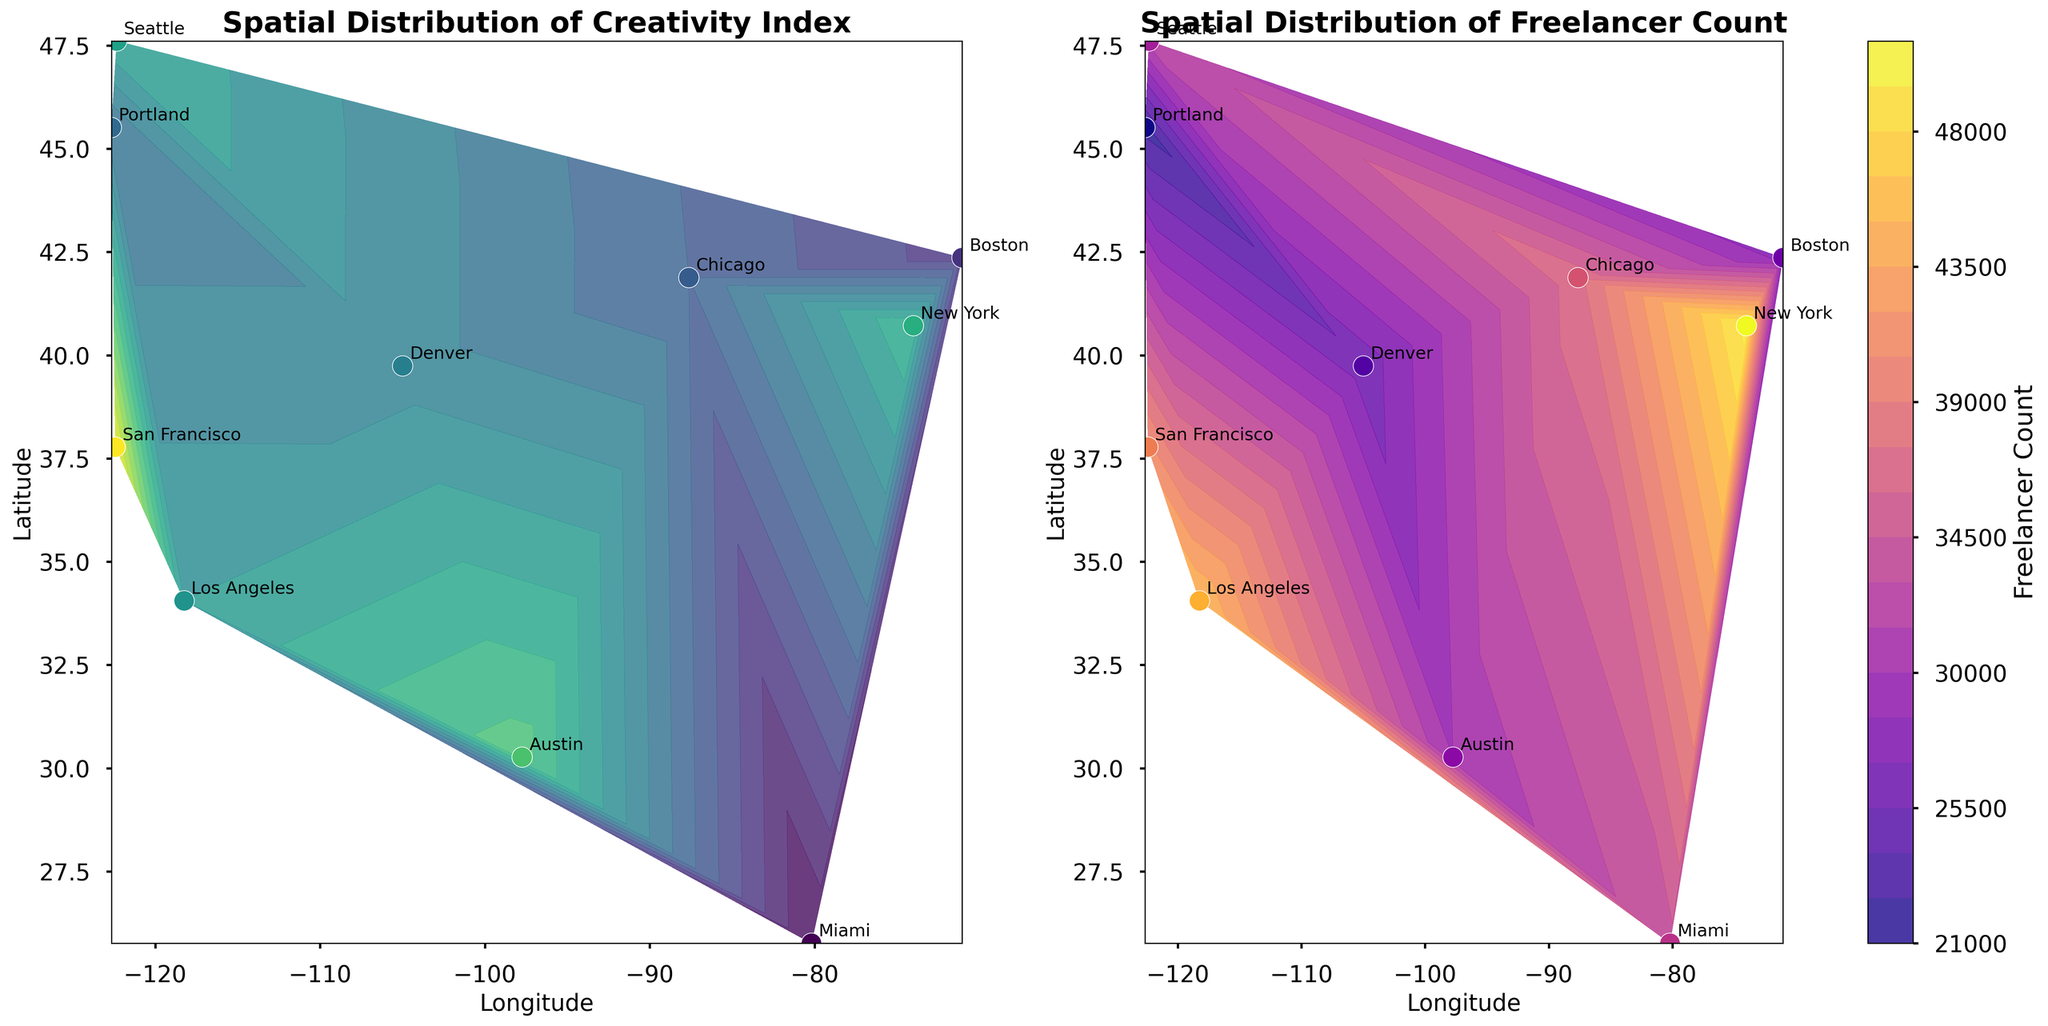What is the title of the left subplot? The title of the left subplot can be found at the top of the subplot. It reads "Spatial Distribution of Creativity Index".
Answer: Spatial Distribution of Creativity Index What color represents high Creativity Index values on the left subplot? In the left subplot, high Creativity Index values are represented using a color gradient that goes from lighter to darker. The darker shades (deep purple) indicate higher Creativity Index values.
Answer: Dark purple Which city has the highest Creativity Index? By looking at the contour and the scatter plot, we can see that San Francisco has the highest Creativity Index based on the positioning of the points and their corresponding values.
Answer: San Francisco Which city is geographically the northernmost based on the plots? By comparing the Latitude values on the Y-axis, Seattle appears to be the northernmost city on the plots.
Answer: Seattle Which city has the smallest Freelancer Count? By referring to the right subplot, Portland appears to have the smallest Freelancer Count as indicated by the color and the label of 22,000.
Answer: Portland Which city has a higher Freelancer Count: Miami or Denver? In the right subplot, we compare the colors and the labels of both cities. Miami has 34,000 freelancers, which is higher than Denver's 26,000 freelancers.
Answer: Miami Does a high Creativity Index correlate with a high Freelancer Count? Comparing both subplots, cities with high Creativity Indices, like San Francisco and New York, also appear to have high Freelancer Counts, suggesting a positive correlation.
Answer: Yes How do the Freelancer Counts in Austin and Boston compare using the contour levels? Referring to the color and scatter plots, Austin with 30,000 freelancers is higher than Boston with 28,000 freelancers, though they are relatively close on the contour.
Answer: Austin has a higher Freelancer Count Which city has the highest Community Index based on the colors provided? By checking the data labels, New York has the highest Community Index of 85 among the cities listed.
Answer: New York What is the average Freelancer Count of cities with a Creativity Index above 70? Cities with Creativity Index above 70 are San Francisco (41,000), Austin (30,000), and New York (50,000). The average Freelancer Count is (41,000 + 30,000 + 50,000) / 3 = 121,000 / 3 = 40,333.
Answer: 40,333 